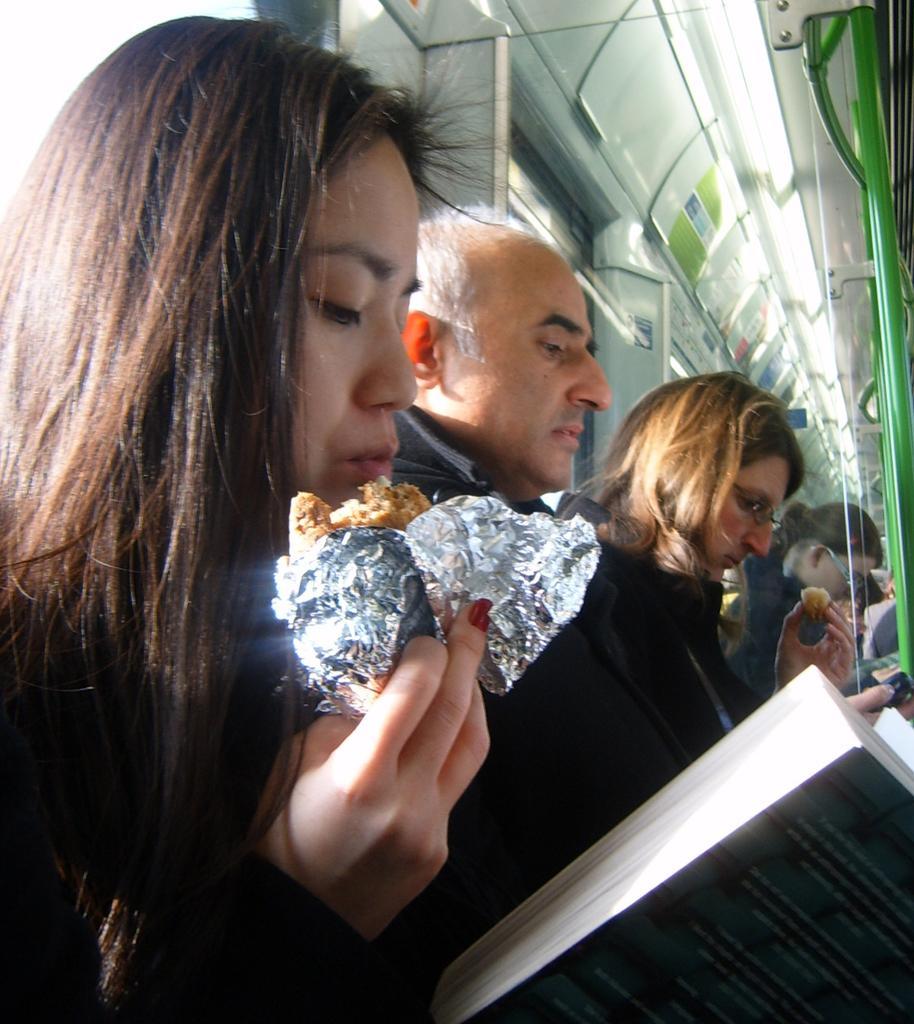Please provide a concise description of this image. In this picture there is interior of a train where there is a woman sitting and holding a book in one of her hand and an edible in her another hand and there are few other persons sitting beside her and there are few lights and some other objects in the background. 